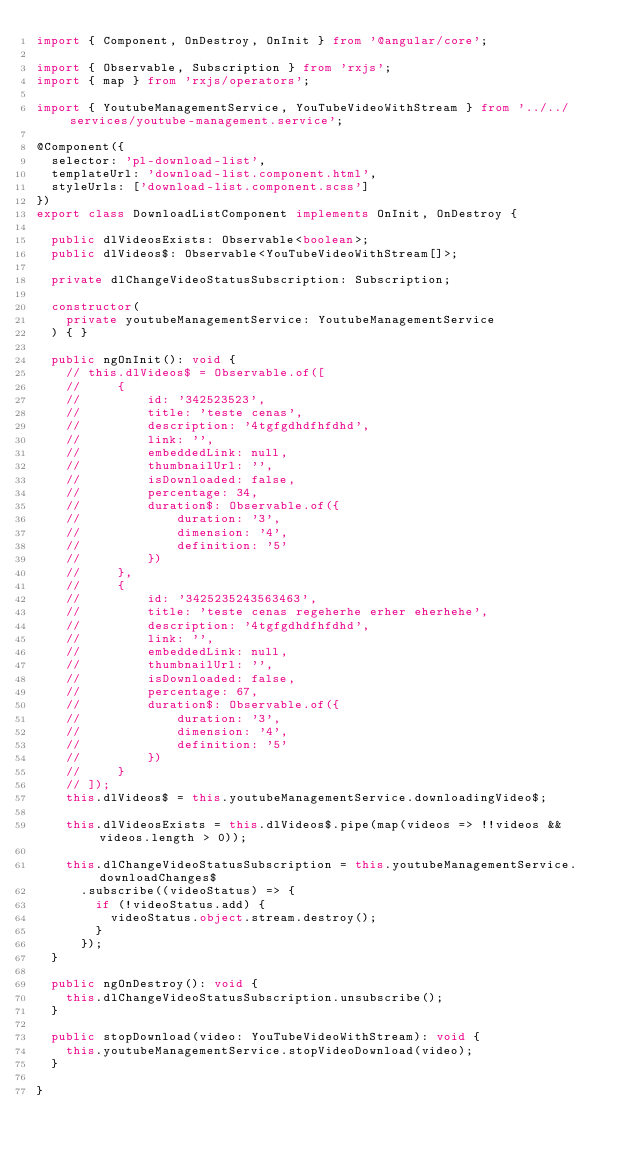Convert code to text. <code><loc_0><loc_0><loc_500><loc_500><_TypeScript_>import { Component, OnDestroy, OnInit } from '@angular/core';

import { Observable, Subscription } from 'rxjs';
import { map } from 'rxjs/operators';

import { YoutubeManagementService, YouTubeVideoWithStream } from '../../services/youtube-management.service';

@Component({
  selector: 'pl-download-list',
  templateUrl: 'download-list.component.html',
  styleUrls: ['download-list.component.scss']
})
export class DownloadListComponent implements OnInit, OnDestroy {

  public dlVideosExists: Observable<boolean>;
  public dlVideos$: Observable<YouTubeVideoWithStream[]>;

  private dlChangeVideoStatusSubscription: Subscription;

  constructor(
    private youtubeManagementService: YoutubeManagementService
  ) { }

  public ngOnInit(): void {
    // this.dlVideos$ = Observable.of([
    //     {
    //         id: '342523523',
    //         title: 'teste cenas',
    //         description: '4tgfgdhdfhfdhd',
    //         link: '',
    //         embeddedLink: null,
    //         thumbnailUrl: '',
    //         isDownloaded: false,
    //         percentage: 34,
    //         duration$: Observable.of({
    //             duration: '3',
    //             dimension: '4',
    //             definition: '5'
    //         })
    //     },
    //     {
    //         id: '3425235243563463',
    //         title: 'teste cenas regeherhe erher eherhehe',
    //         description: '4tgfgdhdfhfdhd',
    //         link: '',
    //         embeddedLink: null,
    //         thumbnailUrl: '',
    //         isDownloaded: false,
    //         percentage: 67,
    //         duration$: Observable.of({
    //             duration: '3',
    //             dimension: '4',
    //             definition: '5'
    //         })
    //     }
    // ]);
    this.dlVideos$ = this.youtubeManagementService.downloadingVideo$;

    this.dlVideosExists = this.dlVideos$.pipe(map(videos => !!videos && videos.length > 0));

    this.dlChangeVideoStatusSubscription = this.youtubeManagementService.downloadChanges$
      .subscribe((videoStatus) => {
        if (!videoStatus.add) {
          videoStatus.object.stream.destroy();
        }
      });
  }

  public ngOnDestroy(): void {
    this.dlChangeVideoStatusSubscription.unsubscribe();
  }

  public stopDownload(video: YouTubeVideoWithStream): void {
    this.youtubeManagementService.stopVideoDownload(video);
  }

}
</code> 